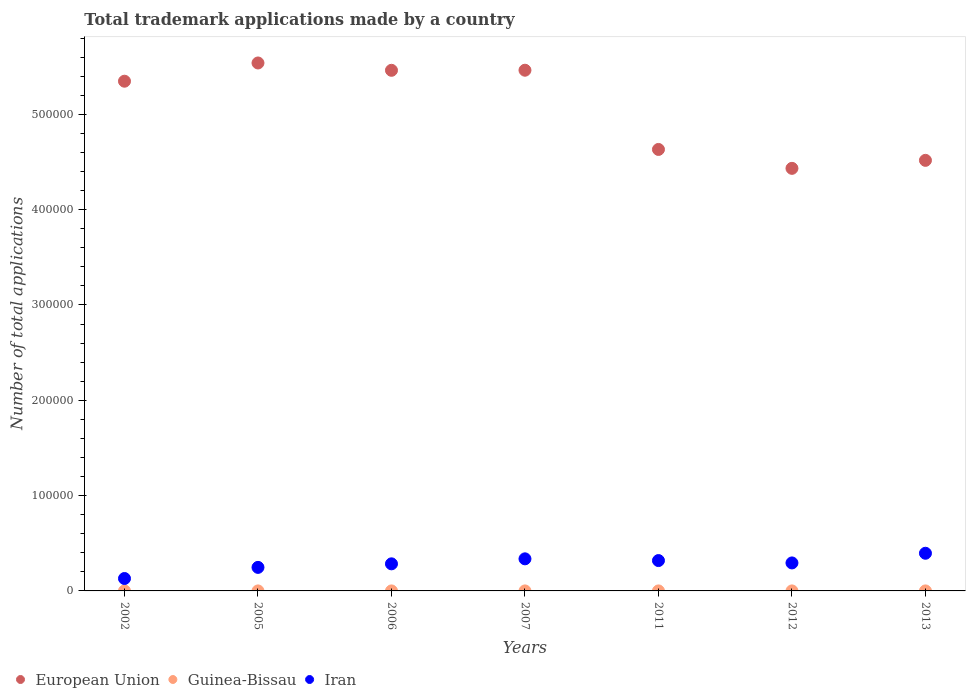Is the number of dotlines equal to the number of legend labels?
Provide a succinct answer. Yes. What is the number of applications made by in European Union in 2011?
Your answer should be very brief. 4.63e+05. Across all years, what is the maximum number of applications made by in European Union?
Ensure brevity in your answer.  5.54e+05. Across all years, what is the minimum number of applications made by in European Union?
Give a very brief answer. 4.43e+05. In which year was the number of applications made by in Iran maximum?
Keep it short and to the point. 2013. What is the total number of applications made by in Iran in the graph?
Give a very brief answer. 2.01e+05. What is the difference between the number of applications made by in Guinea-Bissau in 2005 and the number of applications made by in Iran in 2012?
Keep it short and to the point. -2.94e+04. What is the average number of applications made by in European Union per year?
Your answer should be compact. 5.06e+05. In the year 2006, what is the difference between the number of applications made by in Guinea-Bissau and number of applications made by in Iran?
Offer a very short reply. -2.84e+04. In how many years, is the number of applications made by in Guinea-Bissau greater than 180000?
Your answer should be very brief. 0. What is the ratio of the number of applications made by in European Union in 2002 to that in 2006?
Your answer should be very brief. 0.98. Is the number of applications made by in Iran in 2006 less than that in 2013?
Ensure brevity in your answer.  Yes. What is the difference between the highest and the second highest number of applications made by in European Union?
Provide a short and direct response. 7604. What is the difference between the highest and the lowest number of applications made by in European Union?
Your answer should be very brief. 1.11e+05. Is the sum of the number of applications made by in European Union in 2005 and 2012 greater than the maximum number of applications made by in Guinea-Bissau across all years?
Keep it short and to the point. Yes. Does the number of applications made by in Iran monotonically increase over the years?
Your answer should be compact. No. Is the number of applications made by in Guinea-Bissau strictly less than the number of applications made by in Iran over the years?
Your answer should be very brief. Yes. How many dotlines are there?
Your answer should be compact. 3. How many years are there in the graph?
Give a very brief answer. 7. What is the difference between two consecutive major ticks on the Y-axis?
Offer a very short reply. 1.00e+05. Where does the legend appear in the graph?
Keep it short and to the point. Bottom left. How many legend labels are there?
Make the answer very short. 3. How are the legend labels stacked?
Ensure brevity in your answer.  Horizontal. What is the title of the graph?
Offer a terse response. Total trademark applications made by a country. Does "Central Europe" appear as one of the legend labels in the graph?
Ensure brevity in your answer.  No. What is the label or title of the X-axis?
Provide a short and direct response. Years. What is the label or title of the Y-axis?
Provide a short and direct response. Number of total applications. What is the Number of total applications of European Union in 2002?
Your answer should be compact. 5.35e+05. What is the Number of total applications of Guinea-Bissau in 2002?
Your answer should be very brief. 5. What is the Number of total applications in Iran in 2002?
Your response must be concise. 1.30e+04. What is the Number of total applications in European Union in 2005?
Give a very brief answer. 5.54e+05. What is the Number of total applications of Guinea-Bissau in 2005?
Give a very brief answer. 4. What is the Number of total applications of Iran in 2005?
Offer a very short reply. 2.47e+04. What is the Number of total applications in European Union in 2006?
Keep it short and to the point. 5.46e+05. What is the Number of total applications in Guinea-Bissau in 2006?
Give a very brief answer. 5. What is the Number of total applications in Iran in 2006?
Ensure brevity in your answer.  2.84e+04. What is the Number of total applications of European Union in 2007?
Offer a terse response. 5.46e+05. What is the Number of total applications in Guinea-Bissau in 2007?
Provide a short and direct response. 6. What is the Number of total applications of Iran in 2007?
Your response must be concise. 3.37e+04. What is the Number of total applications in European Union in 2011?
Offer a very short reply. 4.63e+05. What is the Number of total applications in Guinea-Bissau in 2011?
Your response must be concise. 11. What is the Number of total applications of Iran in 2011?
Keep it short and to the point. 3.18e+04. What is the Number of total applications in European Union in 2012?
Your response must be concise. 4.43e+05. What is the Number of total applications in Guinea-Bissau in 2012?
Ensure brevity in your answer.  12. What is the Number of total applications in Iran in 2012?
Make the answer very short. 2.94e+04. What is the Number of total applications of European Union in 2013?
Your answer should be very brief. 4.52e+05. What is the Number of total applications in Guinea-Bissau in 2013?
Offer a very short reply. 14. What is the Number of total applications of Iran in 2013?
Your answer should be compact. 3.95e+04. Across all years, what is the maximum Number of total applications in European Union?
Ensure brevity in your answer.  5.54e+05. Across all years, what is the maximum Number of total applications in Guinea-Bissau?
Offer a very short reply. 14. Across all years, what is the maximum Number of total applications in Iran?
Make the answer very short. 3.95e+04. Across all years, what is the minimum Number of total applications of European Union?
Your response must be concise. 4.43e+05. Across all years, what is the minimum Number of total applications in Iran?
Offer a very short reply. 1.30e+04. What is the total Number of total applications of European Union in the graph?
Ensure brevity in your answer.  3.54e+06. What is the total Number of total applications of Guinea-Bissau in the graph?
Ensure brevity in your answer.  57. What is the total Number of total applications in Iran in the graph?
Make the answer very short. 2.01e+05. What is the difference between the Number of total applications of European Union in 2002 and that in 2005?
Offer a very short reply. -1.91e+04. What is the difference between the Number of total applications in Iran in 2002 and that in 2005?
Provide a succinct answer. -1.17e+04. What is the difference between the Number of total applications of European Union in 2002 and that in 2006?
Offer a terse response. -1.14e+04. What is the difference between the Number of total applications in Guinea-Bissau in 2002 and that in 2006?
Offer a terse response. 0. What is the difference between the Number of total applications of Iran in 2002 and that in 2006?
Offer a very short reply. -1.54e+04. What is the difference between the Number of total applications in European Union in 2002 and that in 2007?
Your answer should be compact. -1.15e+04. What is the difference between the Number of total applications in Guinea-Bissau in 2002 and that in 2007?
Make the answer very short. -1. What is the difference between the Number of total applications of Iran in 2002 and that in 2007?
Your answer should be very brief. -2.06e+04. What is the difference between the Number of total applications in European Union in 2002 and that in 2011?
Make the answer very short. 7.16e+04. What is the difference between the Number of total applications of Iran in 2002 and that in 2011?
Ensure brevity in your answer.  -1.88e+04. What is the difference between the Number of total applications of European Union in 2002 and that in 2012?
Your response must be concise. 9.14e+04. What is the difference between the Number of total applications of Iran in 2002 and that in 2012?
Offer a very short reply. -1.63e+04. What is the difference between the Number of total applications in European Union in 2002 and that in 2013?
Keep it short and to the point. 8.30e+04. What is the difference between the Number of total applications in Guinea-Bissau in 2002 and that in 2013?
Keep it short and to the point. -9. What is the difference between the Number of total applications in Iran in 2002 and that in 2013?
Provide a short and direct response. -2.65e+04. What is the difference between the Number of total applications in European Union in 2005 and that in 2006?
Your answer should be very brief. 7694. What is the difference between the Number of total applications in Iran in 2005 and that in 2006?
Your answer should be very brief. -3724. What is the difference between the Number of total applications of European Union in 2005 and that in 2007?
Keep it short and to the point. 7604. What is the difference between the Number of total applications in Guinea-Bissau in 2005 and that in 2007?
Keep it short and to the point. -2. What is the difference between the Number of total applications in Iran in 2005 and that in 2007?
Offer a terse response. -8971. What is the difference between the Number of total applications in European Union in 2005 and that in 2011?
Ensure brevity in your answer.  9.07e+04. What is the difference between the Number of total applications of Guinea-Bissau in 2005 and that in 2011?
Ensure brevity in your answer.  -7. What is the difference between the Number of total applications of Iran in 2005 and that in 2011?
Your answer should be compact. -7153. What is the difference between the Number of total applications in European Union in 2005 and that in 2012?
Give a very brief answer. 1.11e+05. What is the difference between the Number of total applications of Guinea-Bissau in 2005 and that in 2012?
Offer a terse response. -8. What is the difference between the Number of total applications of Iran in 2005 and that in 2012?
Give a very brief answer. -4671. What is the difference between the Number of total applications in European Union in 2005 and that in 2013?
Provide a short and direct response. 1.02e+05. What is the difference between the Number of total applications in Guinea-Bissau in 2005 and that in 2013?
Offer a terse response. -10. What is the difference between the Number of total applications in Iran in 2005 and that in 2013?
Offer a very short reply. -1.48e+04. What is the difference between the Number of total applications in European Union in 2006 and that in 2007?
Your response must be concise. -90. What is the difference between the Number of total applications in Iran in 2006 and that in 2007?
Offer a very short reply. -5247. What is the difference between the Number of total applications of European Union in 2006 and that in 2011?
Make the answer very short. 8.30e+04. What is the difference between the Number of total applications in Guinea-Bissau in 2006 and that in 2011?
Your answer should be very brief. -6. What is the difference between the Number of total applications of Iran in 2006 and that in 2011?
Offer a terse response. -3429. What is the difference between the Number of total applications in European Union in 2006 and that in 2012?
Your answer should be very brief. 1.03e+05. What is the difference between the Number of total applications in Guinea-Bissau in 2006 and that in 2012?
Make the answer very short. -7. What is the difference between the Number of total applications of Iran in 2006 and that in 2012?
Ensure brevity in your answer.  -947. What is the difference between the Number of total applications of European Union in 2006 and that in 2013?
Your answer should be very brief. 9.45e+04. What is the difference between the Number of total applications of Iran in 2006 and that in 2013?
Offer a terse response. -1.11e+04. What is the difference between the Number of total applications of European Union in 2007 and that in 2011?
Give a very brief answer. 8.31e+04. What is the difference between the Number of total applications in Iran in 2007 and that in 2011?
Make the answer very short. 1818. What is the difference between the Number of total applications of European Union in 2007 and that in 2012?
Provide a succinct answer. 1.03e+05. What is the difference between the Number of total applications in Iran in 2007 and that in 2012?
Offer a terse response. 4300. What is the difference between the Number of total applications of European Union in 2007 and that in 2013?
Ensure brevity in your answer.  9.46e+04. What is the difference between the Number of total applications in Guinea-Bissau in 2007 and that in 2013?
Ensure brevity in your answer.  -8. What is the difference between the Number of total applications of Iran in 2007 and that in 2013?
Keep it short and to the point. -5851. What is the difference between the Number of total applications of European Union in 2011 and that in 2012?
Keep it short and to the point. 1.98e+04. What is the difference between the Number of total applications of Iran in 2011 and that in 2012?
Provide a short and direct response. 2482. What is the difference between the Number of total applications in European Union in 2011 and that in 2013?
Keep it short and to the point. 1.14e+04. What is the difference between the Number of total applications in Iran in 2011 and that in 2013?
Offer a very short reply. -7669. What is the difference between the Number of total applications of European Union in 2012 and that in 2013?
Ensure brevity in your answer.  -8390. What is the difference between the Number of total applications in Guinea-Bissau in 2012 and that in 2013?
Your answer should be compact. -2. What is the difference between the Number of total applications in Iran in 2012 and that in 2013?
Your answer should be very brief. -1.02e+04. What is the difference between the Number of total applications of European Union in 2002 and the Number of total applications of Guinea-Bissau in 2005?
Your answer should be compact. 5.35e+05. What is the difference between the Number of total applications in European Union in 2002 and the Number of total applications in Iran in 2005?
Make the answer very short. 5.10e+05. What is the difference between the Number of total applications of Guinea-Bissau in 2002 and the Number of total applications of Iran in 2005?
Give a very brief answer. -2.47e+04. What is the difference between the Number of total applications of European Union in 2002 and the Number of total applications of Guinea-Bissau in 2006?
Your answer should be compact. 5.35e+05. What is the difference between the Number of total applications of European Union in 2002 and the Number of total applications of Iran in 2006?
Your answer should be compact. 5.06e+05. What is the difference between the Number of total applications of Guinea-Bissau in 2002 and the Number of total applications of Iran in 2006?
Your answer should be very brief. -2.84e+04. What is the difference between the Number of total applications of European Union in 2002 and the Number of total applications of Guinea-Bissau in 2007?
Your answer should be very brief. 5.35e+05. What is the difference between the Number of total applications of European Union in 2002 and the Number of total applications of Iran in 2007?
Your answer should be compact. 5.01e+05. What is the difference between the Number of total applications in Guinea-Bissau in 2002 and the Number of total applications in Iran in 2007?
Keep it short and to the point. -3.37e+04. What is the difference between the Number of total applications in European Union in 2002 and the Number of total applications in Guinea-Bissau in 2011?
Keep it short and to the point. 5.35e+05. What is the difference between the Number of total applications of European Union in 2002 and the Number of total applications of Iran in 2011?
Offer a terse response. 5.03e+05. What is the difference between the Number of total applications in Guinea-Bissau in 2002 and the Number of total applications in Iran in 2011?
Your answer should be compact. -3.18e+04. What is the difference between the Number of total applications in European Union in 2002 and the Number of total applications in Guinea-Bissau in 2012?
Your answer should be very brief. 5.35e+05. What is the difference between the Number of total applications of European Union in 2002 and the Number of total applications of Iran in 2012?
Your answer should be very brief. 5.05e+05. What is the difference between the Number of total applications in Guinea-Bissau in 2002 and the Number of total applications in Iran in 2012?
Your response must be concise. -2.94e+04. What is the difference between the Number of total applications in European Union in 2002 and the Number of total applications in Guinea-Bissau in 2013?
Give a very brief answer. 5.35e+05. What is the difference between the Number of total applications of European Union in 2002 and the Number of total applications of Iran in 2013?
Your response must be concise. 4.95e+05. What is the difference between the Number of total applications of Guinea-Bissau in 2002 and the Number of total applications of Iran in 2013?
Keep it short and to the point. -3.95e+04. What is the difference between the Number of total applications of European Union in 2005 and the Number of total applications of Guinea-Bissau in 2006?
Ensure brevity in your answer.  5.54e+05. What is the difference between the Number of total applications of European Union in 2005 and the Number of total applications of Iran in 2006?
Your answer should be compact. 5.26e+05. What is the difference between the Number of total applications in Guinea-Bissau in 2005 and the Number of total applications in Iran in 2006?
Ensure brevity in your answer.  -2.84e+04. What is the difference between the Number of total applications of European Union in 2005 and the Number of total applications of Guinea-Bissau in 2007?
Provide a succinct answer. 5.54e+05. What is the difference between the Number of total applications in European Union in 2005 and the Number of total applications in Iran in 2007?
Your response must be concise. 5.20e+05. What is the difference between the Number of total applications of Guinea-Bissau in 2005 and the Number of total applications of Iran in 2007?
Your answer should be very brief. -3.37e+04. What is the difference between the Number of total applications in European Union in 2005 and the Number of total applications in Guinea-Bissau in 2011?
Provide a succinct answer. 5.54e+05. What is the difference between the Number of total applications in European Union in 2005 and the Number of total applications in Iran in 2011?
Ensure brevity in your answer.  5.22e+05. What is the difference between the Number of total applications in Guinea-Bissau in 2005 and the Number of total applications in Iran in 2011?
Provide a short and direct response. -3.18e+04. What is the difference between the Number of total applications of European Union in 2005 and the Number of total applications of Guinea-Bissau in 2012?
Give a very brief answer. 5.54e+05. What is the difference between the Number of total applications of European Union in 2005 and the Number of total applications of Iran in 2012?
Your response must be concise. 5.25e+05. What is the difference between the Number of total applications in Guinea-Bissau in 2005 and the Number of total applications in Iran in 2012?
Keep it short and to the point. -2.94e+04. What is the difference between the Number of total applications in European Union in 2005 and the Number of total applications in Guinea-Bissau in 2013?
Provide a succinct answer. 5.54e+05. What is the difference between the Number of total applications in European Union in 2005 and the Number of total applications in Iran in 2013?
Give a very brief answer. 5.14e+05. What is the difference between the Number of total applications in Guinea-Bissau in 2005 and the Number of total applications in Iran in 2013?
Your answer should be very brief. -3.95e+04. What is the difference between the Number of total applications of European Union in 2006 and the Number of total applications of Guinea-Bissau in 2007?
Your answer should be very brief. 5.46e+05. What is the difference between the Number of total applications of European Union in 2006 and the Number of total applications of Iran in 2007?
Your answer should be compact. 5.13e+05. What is the difference between the Number of total applications of Guinea-Bissau in 2006 and the Number of total applications of Iran in 2007?
Your response must be concise. -3.37e+04. What is the difference between the Number of total applications of European Union in 2006 and the Number of total applications of Guinea-Bissau in 2011?
Provide a succinct answer. 5.46e+05. What is the difference between the Number of total applications in European Union in 2006 and the Number of total applications in Iran in 2011?
Ensure brevity in your answer.  5.14e+05. What is the difference between the Number of total applications in Guinea-Bissau in 2006 and the Number of total applications in Iran in 2011?
Offer a very short reply. -3.18e+04. What is the difference between the Number of total applications in European Union in 2006 and the Number of total applications in Guinea-Bissau in 2012?
Make the answer very short. 5.46e+05. What is the difference between the Number of total applications in European Union in 2006 and the Number of total applications in Iran in 2012?
Offer a terse response. 5.17e+05. What is the difference between the Number of total applications in Guinea-Bissau in 2006 and the Number of total applications in Iran in 2012?
Offer a terse response. -2.94e+04. What is the difference between the Number of total applications in European Union in 2006 and the Number of total applications in Guinea-Bissau in 2013?
Make the answer very short. 5.46e+05. What is the difference between the Number of total applications of European Union in 2006 and the Number of total applications of Iran in 2013?
Your answer should be compact. 5.07e+05. What is the difference between the Number of total applications in Guinea-Bissau in 2006 and the Number of total applications in Iran in 2013?
Provide a succinct answer. -3.95e+04. What is the difference between the Number of total applications in European Union in 2007 and the Number of total applications in Guinea-Bissau in 2011?
Give a very brief answer. 5.46e+05. What is the difference between the Number of total applications in European Union in 2007 and the Number of total applications in Iran in 2011?
Provide a short and direct response. 5.14e+05. What is the difference between the Number of total applications of Guinea-Bissau in 2007 and the Number of total applications of Iran in 2011?
Offer a terse response. -3.18e+04. What is the difference between the Number of total applications in European Union in 2007 and the Number of total applications in Guinea-Bissau in 2012?
Give a very brief answer. 5.46e+05. What is the difference between the Number of total applications of European Union in 2007 and the Number of total applications of Iran in 2012?
Provide a succinct answer. 5.17e+05. What is the difference between the Number of total applications in Guinea-Bissau in 2007 and the Number of total applications in Iran in 2012?
Give a very brief answer. -2.94e+04. What is the difference between the Number of total applications in European Union in 2007 and the Number of total applications in Guinea-Bissau in 2013?
Make the answer very short. 5.46e+05. What is the difference between the Number of total applications of European Union in 2007 and the Number of total applications of Iran in 2013?
Provide a succinct answer. 5.07e+05. What is the difference between the Number of total applications of Guinea-Bissau in 2007 and the Number of total applications of Iran in 2013?
Offer a very short reply. -3.95e+04. What is the difference between the Number of total applications of European Union in 2011 and the Number of total applications of Guinea-Bissau in 2012?
Offer a very short reply. 4.63e+05. What is the difference between the Number of total applications in European Union in 2011 and the Number of total applications in Iran in 2012?
Ensure brevity in your answer.  4.34e+05. What is the difference between the Number of total applications of Guinea-Bissau in 2011 and the Number of total applications of Iran in 2012?
Provide a short and direct response. -2.94e+04. What is the difference between the Number of total applications in European Union in 2011 and the Number of total applications in Guinea-Bissau in 2013?
Make the answer very short. 4.63e+05. What is the difference between the Number of total applications of European Union in 2011 and the Number of total applications of Iran in 2013?
Keep it short and to the point. 4.24e+05. What is the difference between the Number of total applications in Guinea-Bissau in 2011 and the Number of total applications in Iran in 2013?
Provide a succinct answer. -3.95e+04. What is the difference between the Number of total applications in European Union in 2012 and the Number of total applications in Guinea-Bissau in 2013?
Your response must be concise. 4.43e+05. What is the difference between the Number of total applications in European Union in 2012 and the Number of total applications in Iran in 2013?
Keep it short and to the point. 4.04e+05. What is the difference between the Number of total applications in Guinea-Bissau in 2012 and the Number of total applications in Iran in 2013?
Offer a very short reply. -3.95e+04. What is the average Number of total applications in European Union per year?
Provide a succinct answer. 5.06e+05. What is the average Number of total applications in Guinea-Bissau per year?
Your response must be concise. 8.14. What is the average Number of total applications of Iran per year?
Your answer should be very brief. 2.86e+04. In the year 2002, what is the difference between the Number of total applications of European Union and Number of total applications of Guinea-Bissau?
Your answer should be very brief. 5.35e+05. In the year 2002, what is the difference between the Number of total applications in European Union and Number of total applications in Iran?
Give a very brief answer. 5.22e+05. In the year 2002, what is the difference between the Number of total applications in Guinea-Bissau and Number of total applications in Iran?
Offer a terse response. -1.30e+04. In the year 2005, what is the difference between the Number of total applications in European Union and Number of total applications in Guinea-Bissau?
Ensure brevity in your answer.  5.54e+05. In the year 2005, what is the difference between the Number of total applications in European Union and Number of total applications in Iran?
Make the answer very short. 5.29e+05. In the year 2005, what is the difference between the Number of total applications of Guinea-Bissau and Number of total applications of Iran?
Provide a succinct answer. -2.47e+04. In the year 2006, what is the difference between the Number of total applications in European Union and Number of total applications in Guinea-Bissau?
Give a very brief answer. 5.46e+05. In the year 2006, what is the difference between the Number of total applications of European Union and Number of total applications of Iran?
Your answer should be very brief. 5.18e+05. In the year 2006, what is the difference between the Number of total applications in Guinea-Bissau and Number of total applications in Iran?
Provide a succinct answer. -2.84e+04. In the year 2007, what is the difference between the Number of total applications in European Union and Number of total applications in Guinea-Bissau?
Offer a terse response. 5.46e+05. In the year 2007, what is the difference between the Number of total applications in European Union and Number of total applications in Iran?
Give a very brief answer. 5.13e+05. In the year 2007, what is the difference between the Number of total applications in Guinea-Bissau and Number of total applications in Iran?
Offer a very short reply. -3.37e+04. In the year 2011, what is the difference between the Number of total applications of European Union and Number of total applications of Guinea-Bissau?
Give a very brief answer. 4.63e+05. In the year 2011, what is the difference between the Number of total applications in European Union and Number of total applications in Iran?
Your response must be concise. 4.31e+05. In the year 2011, what is the difference between the Number of total applications of Guinea-Bissau and Number of total applications of Iran?
Provide a short and direct response. -3.18e+04. In the year 2012, what is the difference between the Number of total applications of European Union and Number of total applications of Guinea-Bissau?
Provide a succinct answer. 4.43e+05. In the year 2012, what is the difference between the Number of total applications of European Union and Number of total applications of Iran?
Your response must be concise. 4.14e+05. In the year 2012, what is the difference between the Number of total applications of Guinea-Bissau and Number of total applications of Iran?
Offer a terse response. -2.94e+04. In the year 2013, what is the difference between the Number of total applications in European Union and Number of total applications in Guinea-Bissau?
Your answer should be compact. 4.52e+05. In the year 2013, what is the difference between the Number of total applications of European Union and Number of total applications of Iran?
Offer a very short reply. 4.12e+05. In the year 2013, what is the difference between the Number of total applications of Guinea-Bissau and Number of total applications of Iran?
Ensure brevity in your answer.  -3.95e+04. What is the ratio of the Number of total applications of European Union in 2002 to that in 2005?
Offer a very short reply. 0.97. What is the ratio of the Number of total applications of Guinea-Bissau in 2002 to that in 2005?
Your response must be concise. 1.25. What is the ratio of the Number of total applications in Iran in 2002 to that in 2005?
Give a very brief answer. 0.53. What is the ratio of the Number of total applications in European Union in 2002 to that in 2006?
Provide a short and direct response. 0.98. What is the ratio of the Number of total applications in Iran in 2002 to that in 2006?
Ensure brevity in your answer.  0.46. What is the ratio of the Number of total applications of European Union in 2002 to that in 2007?
Give a very brief answer. 0.98. What is the ratio of the Number of total applications of Guinea-Bissau in 2002 to that in 2007?
Provide a short and direct response. 0.83. What is the ratio of the Number of total applications of Iran in 2002 to that in 2007?
Your response must be concise. 0.39. What is the ratio of the Number of total applications of European Union in 2002 to that in 2011?
Your response must be concise. 1.15. What is the ratio of the Number of total applications of Guinea-Bissau in 2002 to that in 2011?
Your answer should be compact. 0.45. What is the ratio of the Number of total applications of Iran in 2002 to that in 2011?
Offer a terse response. 0.41. What is the ratio of the Number of total applications in European Union in 2002 to that in 2012?
Provide a succinct answer. 1.21. What is the ratio of the Number of total applications in Guinea-Bissau in 2002 to that in 2012?
Offer a very short reply. 0.42. What is the ratio of the Number of total applications in Iran in 2002 to that in 2012?
Provide a succinct answer. 0.44. What is the ratio of the Number of total applications of European Union in 2002 to that in 2013?
Offer a terse response. 1.18. What is the ratio of the Number of total applications in Guinea-Bissau in 2002 to that in 2013?
Offer a very short reply. 0.36. What is the ratio of the Number of total applications of Iran in 2002 to that in 2013?
Give a very brief answer. 0.33. What is the ratio of the Number of total applications in European Union in 2005 to that in 2006?
Give a very brief answer. 1.01. What is the ratio of the Number of total applications of Iran in 2005 to that in 2006?
Give a very brief answer. 0.87. What is the ratio of the Number of total applications of European Union in 2005 to that in 2007?
Your response must be concise. 1.01. What is the ratio of the Number of total applications in Iran in 2005 to that in 2007?
Your answer should be compact. 0.73. What is the ratio of the Number of total applications in European Union in 2005 to that in 2011?
Ensure brevity in your answer.  1.2. What is the ratio of the Number of total applications of Guinea-Bissau in 2005 to that in 2011?
Give a very brief answer. 0.36. What is the ratio of the Number of total applications of Iran in 2005 to that in 2011?
Make the answer very short. 0.78. What is the ratio of the Number of total applications in European Union in 2005 to that in 2012?
Provide a short and direct response. 1.25. What is the ratio of the Number of total applications of Guinea-Bissau in 2005 to that in 2012?
Make the answer very short. 0.33. What is the ratio of the Number of total applications in Iran in 2005 to that in 2012?
Provide a succinct answer. 0.84. What is the ratio of the Number of total applications of European Union in 2005 to that in 2013?
Provide a short and direct response. 1.23. What is the ratio of the Number of total applications of Guinea-Bissau in 2005 to that in 2013?
Keep it short and to the point. 0.29. What is the ratio of the Number of total applications in Iran in 2005 to that in 2013?
Your answer should be very brief. 0.62. What is the ratio of the Number of total applications of Guinea-Bissau in 2006 to that in 2007?
Your answer should be very brief. 0.83. What is the ratio of the Number of total applications in Iran in 2006 to that in 2007?
Your answer should be compact. 0.84. What is the ratio of the Number of total applications in European Union in 2006 to that in 2011?
Your response must be concise. 1.18. What is the ratio of the Number of total applications of Guinea-Bissau in 2006 to that in 2011?
Your answer should be very brief. 0.45. What is the ratio of the Number of total applications in Iran in 2006 to that in 2011?
Your response must be concise. 0.89. What is the ratio of the Number of total applications of European Union in 2006 to that in 2012?
Make the answer very short. 1.23. What is the ratio of the Number of total applications in Guinea-Bissau in 2006 to that in 2012?
Make the answer very short. 0.42. What is the ratio of the Number of total applications of Iran in 2006 to that in 2012?
Make the answer very short. 0.97. What is the ratio of the Number of total applications of European Union in 2006 to that in 2013?
Make the answer very short. 1.21. What is the ratio of the Number of total applications of Guinea-Bissau in 2006 to that in 2013?
Ensure brevity in your answer.  0.36. What is the ratio of the Number of total applications of Iran in 2006 to that in 2013?
Provide a short and direct response. 0.72. What is the ratio of the Number of total applications in European Union in 2007 to that in 2011?
Provide a succinct answer. 1.18. What is the ratio of the Number of total applications in Guinea-Bissau in 2007 to that in 2011?
Your response must be concise. 0.55. What is the ratio of the Number of total applications of Iran in 2007 to that in 2011?
Offer a terse response. 1.06. What is the ratio of the Number of total applications in European Union in 2007 to that in 2012?
Keep it short and to the point. 1.23. What is the ratio of the Number of total applications in Guinea-Bissau in 2007 to that in 2012?
Your answer should be compact. 0.5. What is the ratio of the Number of total applications of Iran in 2007 to that in 2012?
Provide a succinct answer. 1.15. What is the ratio of the Number of total applications of European Union in 2007 to that in 2013?
Keep it short and to the point. 1.21. What is the ratio of the Number of total applications in Guinea-Bissau in 2007 to that in 2013?
Keep it short and to the point. 0.43. What is the ratio of the Number of total applications of Iran in 2007 to that in 2013?
Provide a short and direct response. 0.85. What is the ratio of the Number of total applications in European Union in 2011 to that in 2012?
Make the answer very short. 1.04. What is the ratio of the Number of total applications in Guinea-Bissau in 2011 to that in 2012?
Your response must be concise. 0.92. What is the ratio of the Number of total applications of Iran in 2011 to that in 2012?
Your answer should be very brief. 1.08. What is the ratio of the Number of total applications in European Union in 2011 to that in 2013?
Your response must be concise. 1.03. What is the ratio of the Number of total applications of Guinea-Bissau in 2011 to that in 2013?
Your answer should be compact. 0.79. What is the ratio of the Number of total applications in Iran in 2011 to that in 2013?
Offer a terse response. 0.81. What is the ratio of the Number of total applications in European Union in 2012 to that in 2013?
Provide a succinct answer. 0.98. What is the ratio of the Number of total applications in Guinea-Bissau in 2012 to that in 2013?
Offer a terse response. 0.86. What is the ratio of the Number of total applications of Iran in 2012 to that in 2013?
Offer a terse response. 0.74. What is the difference between the highest and the second highest Number of total applications in European Union?
Keep it short and to the point. 7604. What is the difference between the highest and the second highest Number of total applications of Guinea-Bissau?
Provide a succinct answer. 2. What is the difference between the highest and the second highest Number of total applications of Iran?
Ensure brevity in your answer.  5851. What is the difference between the highest and the lowest Number of total applications of European Union?
Offer a very short reply. 1.11e+05. What is the difference between the highest and the lowest Number of total applications in Guinea-Bissau?
Your answer should be very brief. 10. What is the difference between the highest and the lowest Number of total applications of Iran?
Make the answer very short. 2.65e+04. 